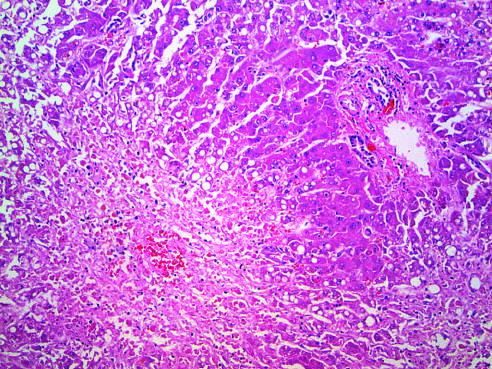what is hepatocellular necrosis caused by?
Answer the question using a single word or phrase. Acetaminophen overdose 